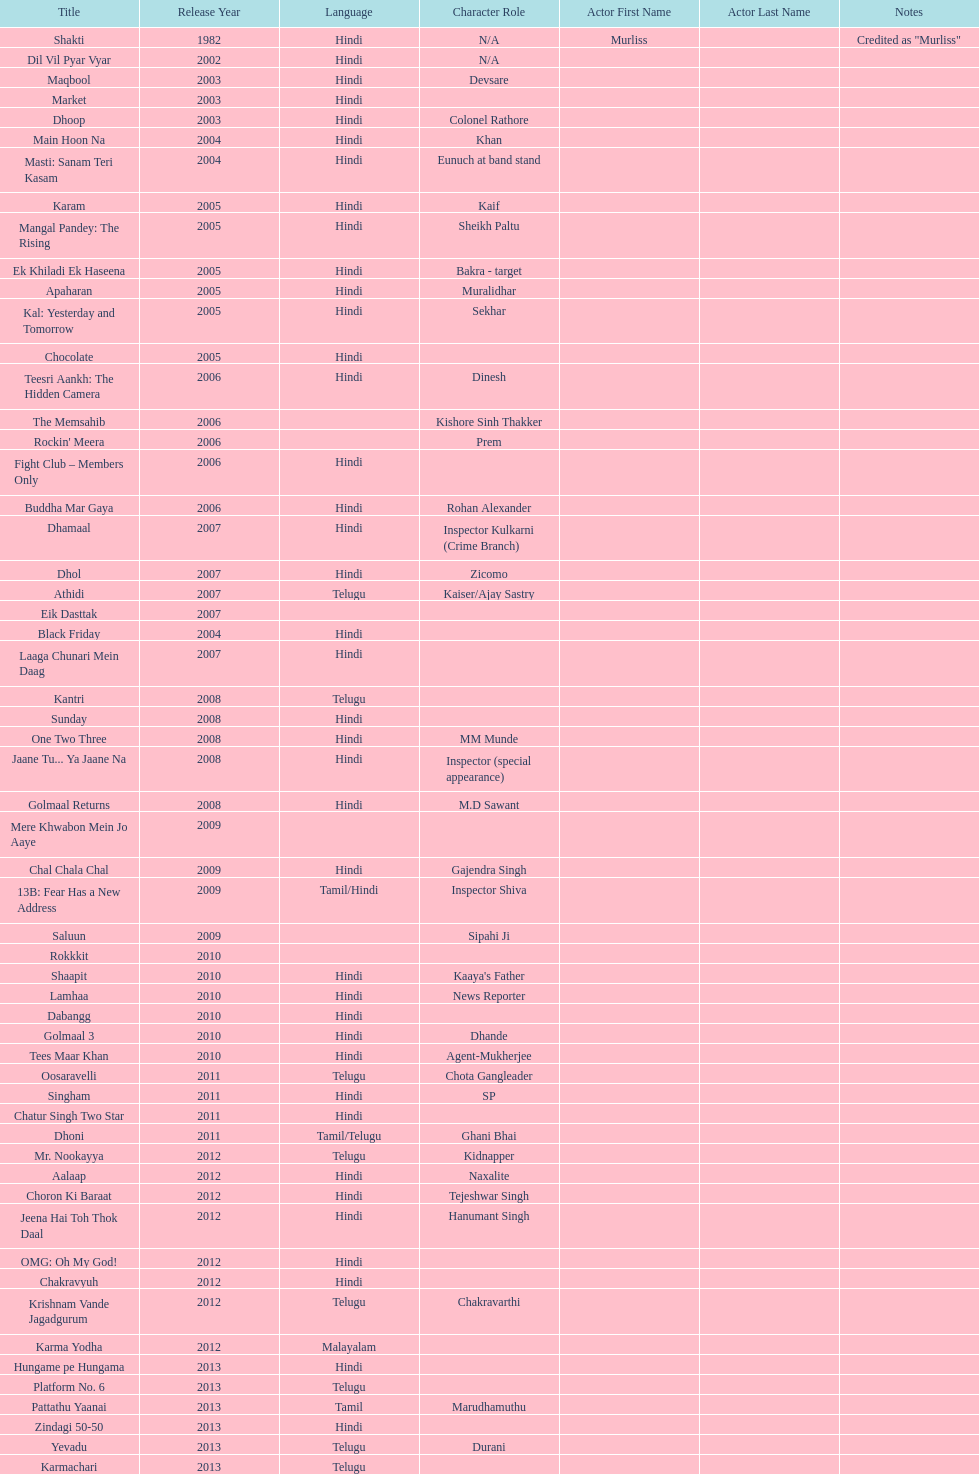What movie did this actor star in after they starred in dil vil pyar vyar in 2002? Maqbool. 